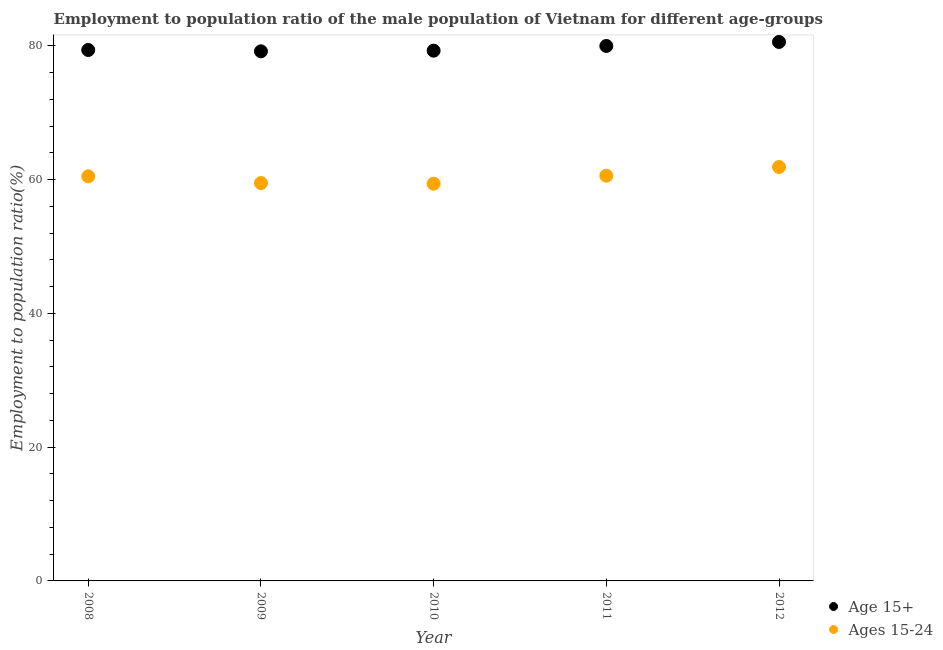What is the employment to population ratio(age 15-24) in 2009?
Your answer should be compact. 59.5. Across all years, what is the maximum employment to population ratio(age 15+)?
Give a very brief answer. 80.6. Across all years, what is the minimum employment to population ratio(age 15-24)?
Offer a terse response. 59.4. In which year was the employment to population ratio(age 15+) maximum?
Provide a short and direct response. 2012. In which year was the employment to population ratio(age 15-24) minimum?
Your answer should be compact. 2010. What is the total employment to population ratio(age 15+) in the graph?
Offer a terse response. 398.5. What is the difference between the employment to population ratio(age 15-24) in 2010 and that in 2011?
Ensure brevity in your answer.  -1.2. What is the difference between the employment to population ratio(age 15-24) in 2011 and the employment to population ratio(age 15+) in 2008?
Give a very brief answer. -18.8. What is the average employment to population ratio(age 15+) per year?
Your answer should be very brief. 79.7. In the year 2012, what is the difference between the employment to population ratio(age 15-24) and employment to population ratio(age 15+)?
Provide a short and direct response. -18.7. In how many years, is the employment to population ratio(age 15+) greater than 56 %?
Ensure brevity in your answer.  5. What is the ratio of the employment to population ratio(age 15-24) in 2009 to that in 2011?
Your response must be concise. 0.98. Is the employment to population ratio(age 15+) in 2009 less than that in 2012?
Your answer should be compact. Yes. What is the difference between the highest and the second highest employment to population ratio(age 15-24)?
Offer a terse response. 1.3. What is the difference between the highest and the lowest employment to population ratio(age 15-24)?
Your answer should be compact. 2.5. In how many years, is the employment to population ratio(age 15-24) greater than the average employment to population ratio(age 15-24) taken over all years?
Provide a succinct answer. 3. Is the sum of the employment to population ratio(age 15+) in 2011 and 2012 greater than the maximum employment to population ratio(age 15-24) across all years?
Your answer should be very brief. Yes. Is the employment to population ratio(age 15+) strictly greater than the employment to population ratio(age 15-24) over the years?
Your response must be concise. Yes. How many dotlines are there?
Offer a very short reply. 2. What is the difference between two consecutive major ticks on the Y-axis?
Offer a terse response. 20. Are the values on the major ticks of Y-axis written in scientific E-notation?
Your answer should be very brief. No. Does the graph contain any zero values?
Give a very brief answer. No. Does the graph contain grids?
Provide a short and direct response. No. How are the legend labels stacked?
Provide a succinct answer. Vertical. What is the title of the graph?
Your response must be concise. Employment to population ratio of the male population of Vietnam for different age-groups. Does "current US$" appear as one of the legend labels in the graph?
Offer a terse response. No. What is the label or title of the X-axis?
Ensure brevity in your answer.  Year. What is the Employment to population ratio(%) in Age 15+ in 2008?
Your response must be concise. 79.4. What is the Employment to population ratio(%) of Ages 15-24 in 2008?
Keep it short and to the point. 60.5. What is the Employment to population ratio(%) of Age 15+ in 2009?
Offer a terse response. 79.2. What is the Employment to population ratio(%) of Ages 15-24 in 2009?
Offer a very short reply. 59.5. What is the Employment to population ratio(%) in Age 15+ in 2010?
Your answer should be compact. 79.3. What is the Employment to population ratio(%) in Ages 15-24 in 2010?
Provide a succinct answer. 59.4. What is the Employment to population ratio(%) in Ages 15-24 in 2011?
Make the answer very short. 60.6. What is the Employment to population ratio(%) in Age 15+ in 2012?
Give a very brief answer. 80.6. What is the Employment to population ratio(%) in Ages 15-24 in 2012?
Provide a succinct answer. 61.9. Across all years, what is the maximum Employment to population ratio(%) of Age 15+?
Keep it short and to the point. 80.6. Across all years, what is the maximum Employment to population ratio(%) in Ages 15-24?
Give a very brief answer. 61.9. Across all years, what is the minimum Employment to population ratio(%) in Age 15+?
Your answer should be compact. 79.2. Across all years, what is the minimum Employment to population ratio(%) of Ages 15-24?
Make the answer very short. 59.4. What is the total Employment to population ratio(%) of Age 15+ in the graph?
Keep it short and to the point. 398.5. What is the total Employment to population ratio(%) of Ages 15-24 in the graph?
Keep it short and to the point. 301.9. What is the difference between the Employment to population ratio(%) in Ages 15-24 in 2008 and that in 2009?
Your answer should be very brief. 1. What is the difference between the Employment to population ratio(%) in Age 15+ in 2008 and that in 2010?
Provide a short and direct response. 0.1. What is the difference between the Employment to population ratio(%) of Ages 15-24 in 2008 and that in 2010?
Offer a very short reply. 1.1. What is the difference between the Employment to population ratio(%) of Age 15+ in 2008 and that in 2011?
Make the answer very short. -0.6. What is the difference between the Employment to population ratio(%) of Ages 15-24 in 2008 and that in 2011?
Make the answer very short. -0.1. What is the difference between the Employment to population ratio(%) in Age 15+ in 2008 and that in 2012?
Offer a terse response. -1.2. What is the difference between the Employment to population ratio(%) of Ages 15-24 in 2008 and that in 2012?
Provide a succinct answer. -1.4. What is the difference between the Employment to population ratio(%) of Age 15+ in 2009 and that in 2010?
Offer a very short reply. -0.1. What is the difference between the Employment to population ratio(%) in Age 15+ in 2009 and that in 2011?
Your response must be concise. -0.8. What is the difference between the Employment to population ratio(%) in Ages 15-24 in 2009 and that in 2011?
Ensure brevity in your answer.  -1.1. What is the difference between the Employment to population ratio(%) in Age 15+ in 2009 and that in 2012?
Your response must be concise. -1.4. What is the difference between the Employment to population ratio(%) in Age 15+ in 2010 and that in 2011?
Ensure brevity in your answer.  -0.7. What is the difference between the Employment to population ratio(%) of Ages 15-24 in 2010 and that in 2011?
Your response must be concise. -1.2. What is the difference between the Employment to population ratio(%) of Age 15+ in 2010 and that in 2012?
Your answer should be very brief. -1.3. What is the difference between the Employment to population ratio(%) of Ages 15-24 in 2010 and that in 2012?
Your answer should be compact. -2.5. What is the difference between the Employment to population ratio(%) in Age 15+ in 2008 and the Employment to population ratio(%) in Ages 15-24 in 2012?
Keep it short and to the point. 17.5. What is the difference between the Employment to population ratio(%) of Age 15+ in 2009 and the Employment to population ratio(%) of Ages 15-24 in 2010?
Make the answer very short. 19.8. What is the difference between the Employment to population ratio(%) of Age 15+ in 2009 and the Employment to population ratio(%) of Ages 15-24 in 2011?
Give a very brief answer. 18.6. What is the difference between the Employment to population ratio(%) in Age 15+ in 2009 and the Employment to population ratio(%) in Ages 15-24 in 2012?
Make the answer very short. 17.3. What is the difference between the Employment to population ratio(%) in Age 15+ in 2010 and the Employment to population ratio(%) in Ages 15-24 in 2011?
Give a very brief answer. 18.7. What is the difference between the Employment to population ratio(%) in Age 15+ in 2010 and the Employment to population ratio(%) in Ages 15-24 in 2012?
Offer a terse response. 17.4. What is the average Employment to population ratio(%) in Age 15+ per year?
Your answer should be compact. 79.7. What is the average Employment to population ratio(%) of Ages 15-24 per year?
Ensure brevity in your answer.  60.38. In the year 2009, what is the difference between the Employment to population ratio(%) in Age 15+ and Employment to population ratio(%) in Ages 15-24?
Your answer should be very brief. 19.7. In the year 2010, what is the difference between the Employment to population ratio(%) in Age 15+ and Employment to population ratio(%) in Ages 15-24?
Provide a succinct answer. 19.9. In the year 2012, what is the difference between the Employment to population ratio(%) in Age 15+ and Employment to population ratio(%) in Ages 15-24?
Keep it short and to the point. 18.7. What is the ratio of the Employment to population ratio(%) of Ages 15-24 in 2008 to that in 2009?
Your answer should be compact. 1.02. What is the ratio of the Employment to population ratio(%) of Age 15+ in 2008 to that in 2010?
Your answer should be compact. 1. What is the ratio of the Employment to population ratio(%) in Ages 15-24 in 2008 to that in 2010?
Your answer should be very brief. 1.02. What is the ratio of the Employment to population ratio(%) of Age 15+ in 2008 to that in 2012?
Your answer should be very brief. 0.99. What is the ratio of the Employment to population ratio(%) of Ages 15-24 in 2008 to that in 2012?
Keep it short and to the point. 0.98. What is the ratio of the Employment to population ratio(%) in Age 15+ in 2009 to that in 2011?
Provide a succinct answer. 0.99. What is the ratio of the Employment to population ratio(%) in Ages 15-24 in 2009 to that in 2011?
Ensure brevity in your answer.  0.98. What is the ratio of the Employment to population ratio(%) in Age 15+ in 2009 to that in 2012?
Ensure brevity in your answer.  0.98. What is the ratio of the Employment to population ratio(%) in Ages 15-24 in 2009 to that in 2012?
Your response must be concise. 0.96. What is the ratio of the Employment to population ratio(%) of Ages 15-24 in 2010 to that in 2011?
Provide a short and direct response. 0.98. What is the ratio of the Employment to population ratio(%) in Age 15+ in 2010 to that in 2012?
Ensure brevity in your answer.  0.98. What is the ratio of the Employment to population ratio(%) in Ages 15-24 in 2010 to that in 2012?
Your answer should be very brief. 0.96. What is the difference between the highest and the second highest Employment to population ratio(%) of Ages 15-24?
Offer a very short reply. 1.3. What is the difference between the highest and the lowest Employment to population ratio(%) in Age 15+?
Provide a succinct answer. 1.4. What is the difference between the highest and the lowest Employment to population ratio(%) in Ages 15-24?
Give a very brief answer. 2.5. 